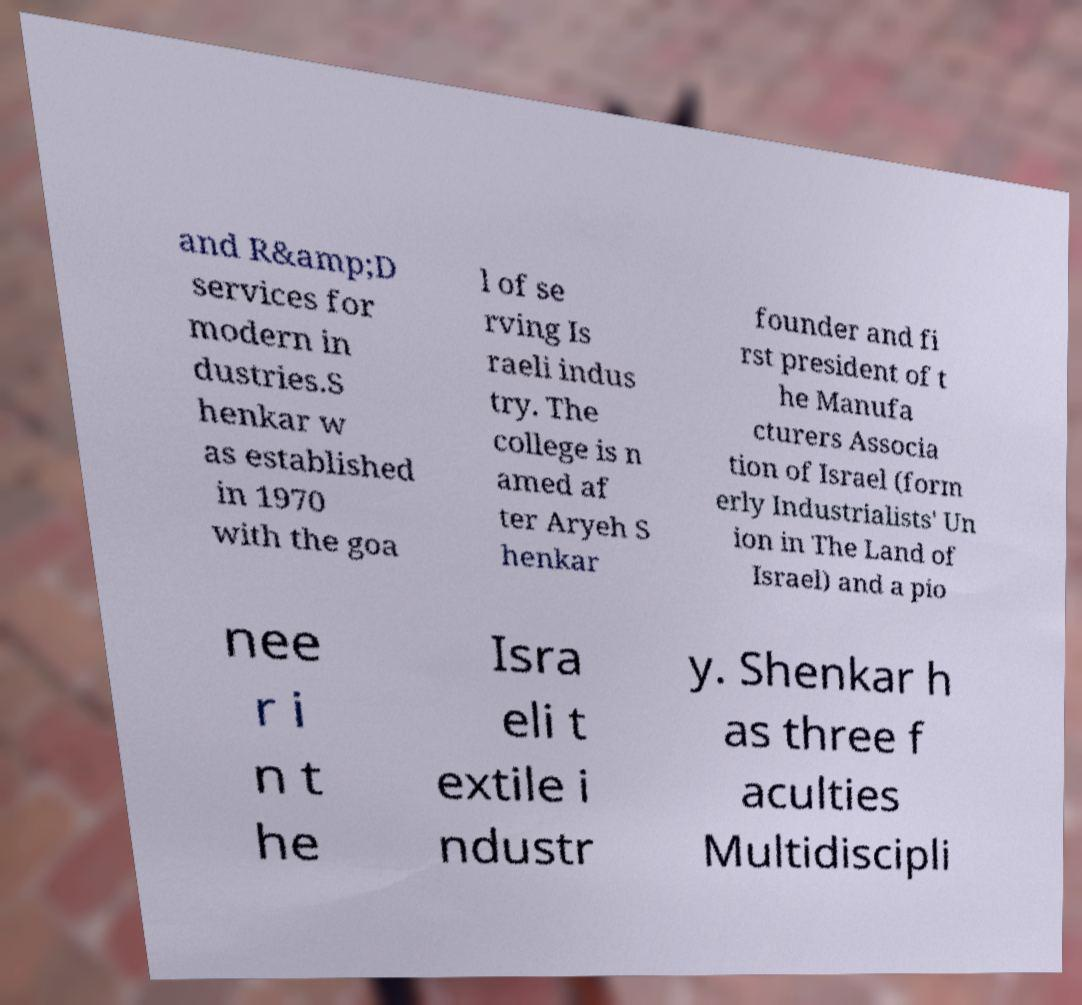Could you extract and type out the text from this image? and R&amp;D services for modern in dustries.S henkar w as established in 1970 with the goa l of se rving Is raeli indus try. The college is n amed af ter Aryeh S henkar founder and fi rst president of t he Manufa cturers Associa tion of Israel (form erly Industrialists' Un ion in The Land of Israel) and a pio nee r i n t he Isra eli t extile i ndustr y. Shenkar h as three f aculties Multidiscipli 